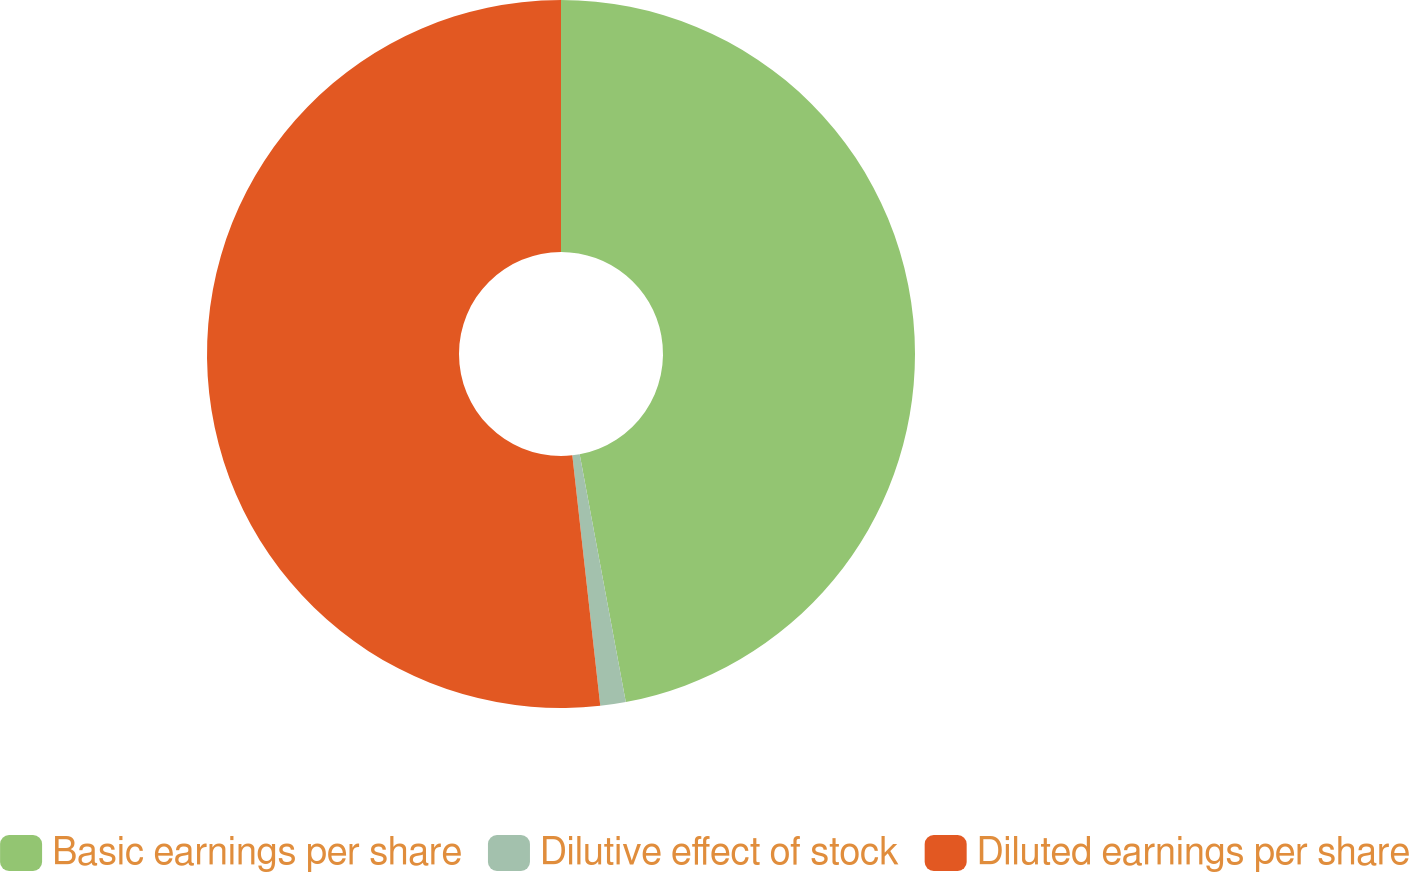Convert chart to OTSL. <chart><loc_0><loc_0><loc_500><loc_500><pie_chart><fcel>Basic earnings per share<fcel>Dilutive effect of stock<fcel>Diluted earnings per share<nl><fcel>47.07%<fcel>1.16%<fcel>51.77%<nl></chart> 